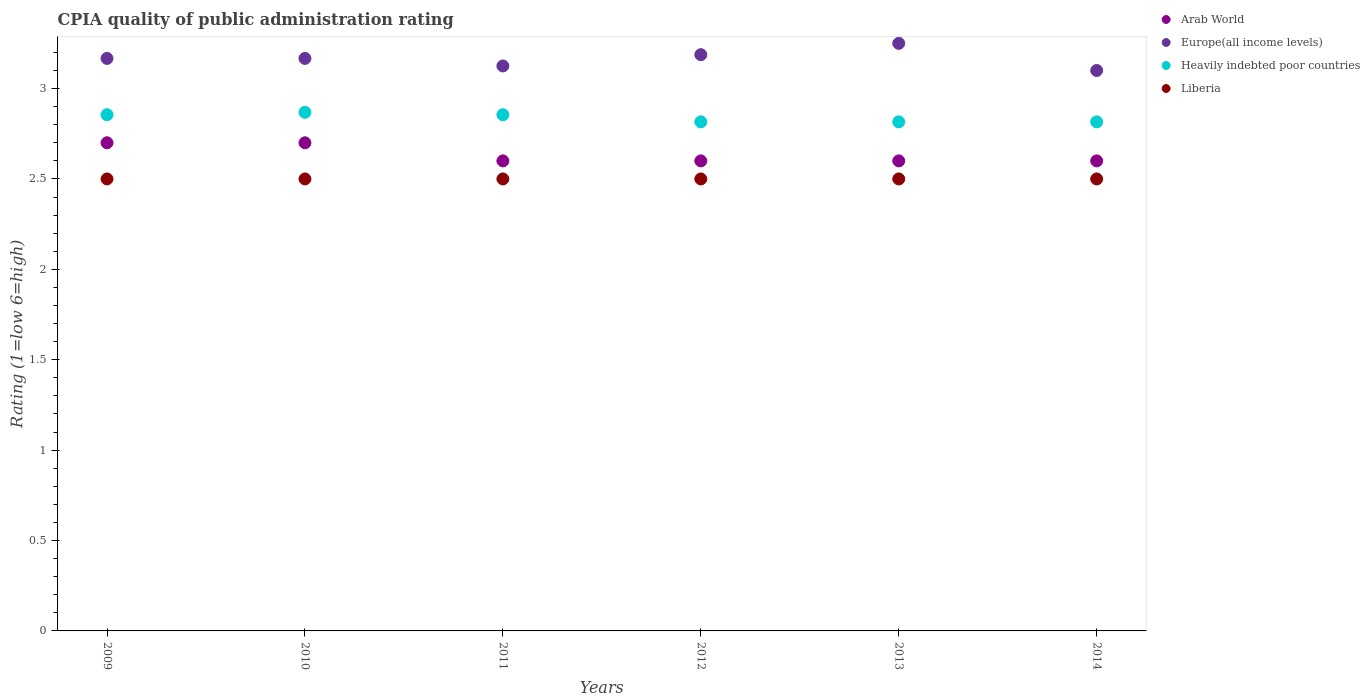How many different coloured dotlines are there?
Give a very brief answer. 4. Is the number of dotlines equal to the number of legend labels?
Ensure brevity in your answer.  Yes. What is the CPIA rating in Liberia in 2009?
Ensure brevity in your answer.  2.5. Across all years, what is the minimum CPIA rating in Heavily indebted poor countries?
Your response must be concise. 2.82. What is the total CPIA rating in Europe(all income levels) in the graph?
Your response must be concise. 19. What is the difference between the CPIA rating in Liberia in 2013 and that in 2014?
Offer a terse response. 0. What is the difference between the CPIA rating in Arab World in 2013 and the CPIA rating in Liberia in 2010?
Ensure brevity in your answer.  0.1. What is the average CPIA rating in Europe(all income levels) per year?
Your answer should be very brief. 3.17. In the year 2014, what is the difference between the CPIA rating in Europe(all income levels) and CPIA rating in Heavily indebted poor countries?
Ensure brevity in your answer.  0.28. In how many years, is the CPIA rating in Europe(all income levels) greater than 0.30000000000000004?
Provide a succinct answer. 6. What is the ratio of the CPIA rating in Liberia in 2009 to that in 2012?
Your response must be concise. 1. Is the CPIA rating in Liberia in 2011 less than that in 2014?
Your answer should be very brief. No. Is the difference between the CPIA rating in Europe(all income levels) in 2009 and 2012 greater than the difference between the CPIA rating in Heavily indebted poor countries in 2009 and 2012?
Make the answer very short. No. What is the difference between the highest and the second highest CPIA rating in Liberia?
Your response must be concise. 0. Is it the case that in every year, the sum of the CPIA rating in Liberia and CPIA rating in Heavily indebted poor countries  is greater than the sum of CPIA rating in Arab World and CPIA rating in Europe(all income levels)?
Offer a terse response. No. Is it the case that in every year, the sum of the CPIA rating in Arab World and CPIA rating in Europe(all income levels)  is greater than the CPIA rating in Heavily indebted poor countries?
Provide a short and direct response. Yes. Does the CPIA rating in Europe(all income levels) monotonically increase over the years?
Your answer should be very brief. No. How many dotlines are there?
Keep it short and to the point. 4. Are the values on the major ticks of Y-axis written in scientific E-notation?
Ensure brevity in your answer.  No. Does the graph contain any zero values?
Your answer should be very brief. No. How are the legend labels stacked?
Keep it short and to the point. Vertical. What is the title of the graph?
Your response must be concise. CPIA quality of public administration rating. Does "Zambia" appear as one of the legend labels in the graph?
Provide a succinct answer. No. What is the label or title of the Y-axis?
Your answer should be compact. Rating (1=low 6=high). What is the Rating (1=low 6=high) in Europe(all income levels) in 2009?
Your answer should be compact. 3.17. What is the Rating (1=low 6=high) in Heavily indebted poor countries in 2009?
Provide a short and direct response. 2.86. What is the Rating (1=low 6=high) of Europe(all income levels) in 2010?
Your response must be concise. 3.17. What is the Rating (1=low 6=high) in Heavily indebted poor countries in 2010?
Keep it short and to the point. 2.87. What is the Rating (1=low 6=high) of Arab World in 2011?
Provide a short and direct response. 2.6. What is the Rating (1=low 6=high) of Europe(all income levels) in 2011?
Provide a succinct answer. 3.12. What is the Rating (1=low 6=high) of Heavily indebted poor countries in 2011?
Keep it short and to the point. 2.86. What is the Rating (1=low 6=high) of Liberia in 2011?
Make the answer very short. 2.5. What is the Rating (1=low 6=high) of Europe(all income levels) in 2012?
Provide a succinct answer. 3.19. What is the Rating (1=low 6=high) in Heavily indebted poor countries in 2012?
Give a very brief answer. 2.82. What is the Rating (1=low 6=high) of Liberia in 2012?
Keep it short and to the point. 2.5. What is the Rating (1=low 6=high) of Arab World in 2013?
Your answer should be very brief. 2.6. What is the Rating (1=low 6=high) in Heavily indebted poor countries in 2013?
Your response must be concise. 2.82. What is the Rating (1=low 6=high) in Liberia in 2013?
Ensure brevity in your answer.  2.5. What is the Rating (1=low 6=high) of Heavily indebted poor countries in 2014?
Ensure brevity in your answer.  2.82. What is the Rating (1=low 6=high) in Liberia in 2014?
Give a very brief answer. 2.5. Across all years, what is the maximum Rating (1=low 6=high) in Heavily indebted poor countries?
Give a very brief answer. 2.87. Across all years, what is the minimum Rating (1=low 6=high) in Heavily indebted poor countries?
Give a very brief answer. 2.82. Across all years, what is the minimum Rating (1=low 6=high) of Liberia?
Make the answer very short. 2.5. What is the total Rating (1=low 6=high) of Arab World in the graph?
Offer a terse response. 15.8. What is the total Rating (1=low 6=high) in Europe(all income levels) in the graph?
Provide a short and direct response. 19. What is the total Rating (1=low 6=high) in Heavily indebted poor countries in the graph?
Ensure brevity in your answer.  17.03. What is the total Rating (1=low 6=high) of Liberia in the graph?
Provide a succinct answer. 15. What is the difference between the Rating (1=low 6=high) in Arab World in 2009 and that in 2010?
Keep it short and to the point. 0. What is the difference between the Rating (1=low 6=high) in Europe(all income levels) in 2009 and that in 2010?
Provide a short and direct response. 0. What is the difference between the Rating (1=low 6=high) in Heavily indebted poor countries in 2009 and that in 2010?
Offer a terse response. -0.01. What is the difference between the Rating (1=low 6=high) of Europe(all income levels) in 2009 and that in 2011?
Your answer should be very brief. 0.04. What is the difference between the Rating (1=low 6=high) in Heavily indebted poor countries in 2009 and that in 2011?
Your answer should be compact. 0. What is the difference between the Rating (1=low 6=high) in Europe(all income levels) in 2009 and that in 2012?
Provide a short and direct response. -0.02. What is the difference between the Rating (1=low 6=high) in Heavily indebted poor countries in 2009 and that in 2012?
Keep it short and to the point. 0.04. What is the difference between the Rating (1=low 6=high) in Europe(all income levels) in 2009 and that in 2013?
Ensure brevity in your answer.  -0.08. What is the difference between the Rating (1=low 6=high) of Heavily indebted poor countries in 2009 and that in 2013?
Make the answer very short. 0.04. What is the difference between the Rating (1=low 6=high) of Europe(all income levels) in 2009 and that in 2014?
Your response must be concise. 0.07. What is the difference between the Rating (1=low 6=high) of Heavily indebted poor countries in 2009 and that in 2014?
Ensure brevity in your answer.  0.04. What is the difference between the Rating (1=low 6=high) in Europe(all income levels) in 2010 and that in 2011?
Keep it short and to the point. 0.04. What is the difference between the Rating (1=low 6=high) of Heavily indebted poor countries in 2010 and that in 2011?
Provide a succinct answer. 0.01. What is the difference between the Rating (1=low 6=high) in Liberia in 2010 and that in 2011?
Ensure brevity in your answer.  0. What is the difference between the Rating (1=low 6=high) in Arab World in 2010 and that in 2012?
Give a very brief answer. 0.1. What is the difference between the Rating (1=low 6=high) of Europe(all income levels) in 2010 and that in 2012?
Provide a short and direct response. -0.02. What is the difference between the Rating (1=low 6=high) of Heavily indebted poor countries in 2010 and that in 2012?
Provide a succinct answer. 0.05. What is the difference between the Rating (1=low 6=high) in Liberia in 2010 and that in 2012?
Give a very brief answer. 0. What is the difference between the Rating (1=low 6=high) of Arab World in 2010 and that in 2013?
Provide a succinct answer. 0.1. What is the difference between the Rating (1=low 6=high) of Europe(all income levels) in 2010 and that in 2013?
Your response must be concise. -0.08. What is the difference between the Rating (1=low 6=high) of Heavily indebted poor countries in 2010 and that in 2013?
Provide a succinct answer. 0.05. What is the difference between the Rating (1=low 6=high) of Europe(all income levels) in 2010 and that in 2014?
Offer a terse response. 0.07. What is the difference between the Rating (1=low 6=high) in Heavily indebted poor countries in 2010 and that in 2014?
Provide a succinct answer. 0.05. What is the difference between the Rating (1=low 6=high) in Liberia in 2010 and that in 2014?
Provide a short and direct response. 0. What is the difference between the Rating (1=low 6=high) in Arab World in 2011 and that in 2012?
Provide a short and direct response. 0. What is the difference between the Rating (1=low 6=high) in Europe(all income levels) in 2011 and that in 2012?
Offer a very short reply. -0.06. What is the difference between the Rating (1=low 6=high) in Heavily indebted poor countries in 2011 and that in 2012?
Keep it short and to the point. 0.04. What is the difference between the Rating (1=low 6=high) of Liberia in 2011 and that in 2012?
Ensure brevity in your answer.  0. What is the difference between the Rating (1=low 6=high) in Europe(all income levels) in 2011 and that in 2013?
Your answer should be compact. -0.12. What is the difference between the Rating (1=low 6=high) in Heavily indebted poor countries in 2011 and that in 2013?
Make the answer very short. 0.04. What is the difference between the Rating (1=low 6=high) of Liberia in 2011 and that in 2013?
Your answer should be compact. 0. What is the difference between the Rating (1=low 6=high) of Arab World in 2011 and that in 2014?
Offer a terse response. 0. What is the difference between the Rating (1=low 6=high) in Europe(all income levels) in 2011 and that in 2014?
Your response must be concise. 0.03. What is the difference between the Rating (1=low 6=high) in Heavily indebted poor countries in 2011 and that in 2014?
Make the answer very short. 0.04. What is the difference between the Rating (1=low 6=high) in Liberia in 2011 and that in 2014?
Keep it short and to the point. 0. What is the difference between the Rating (1=low 6=high) of Arab World in 2012 and that in 2013?
Offer a very short reply. 0. What is the difference between the Rating (1=low 6=high) of Europe(all income levels) in 2012 and that in 2013?
Your answer should be compact. -0.06. What is the difference between the Rating (1=low 6=high) of Europe(all income levels) in 2012 and that in 2014?
Make the answer very short. 0.09. What is the difference between the Rating (1=low 6=high) in Liberia in 2012 and that in 2014?
Provide a succinct answer. 0. What is the difference between the Rating (1=low 6=high) of Arab World in 2013 and that in 2014?
Your answer should be compact. 0. What is the difference between the Rating (1=low 6=high) in Europe(all income levels) in 2013 and that in 2014?
Offer a terse response. 0.15. What is the difference between the Rating (1=low 6=high) in Arab World in 2009 and the Rating (1=low 6=high) in Europe(all income levels) in 2010?
Provide a short and direct response. -0.47. What is the difference between the Rating (1=low 6=high) of Arab World in 2009 and the Rating (1=low 6=high) of Heavily indebted poor countries in 2010?
Ensure brevity in your answer.  -0.17. What is the difference between the Rating (1=low 6=high) of Europe(all income levels) in 2009 and the Rating (1=low 6=high) of Heavily indebted poor countries in 2010?
Ensure brevity in your answer.  0.3. What is the difference between the Rating (1=low 6=high) in Europe(all income levels) in 2009 and the Rating (1=low 6=high) in Liberia in 2010?
Give a very brief answer. 0.67. What is the difference between the Rating (1=low 6=high) of Heavily indebted poor countries in 2009 and the Rating (1=low 6=high) of Liberia in 2010?
Provide a short and direct response. 0.36. What is the difference between the Rating (1=low 6=high) in Arab World in 2009 and the Rating (1=low 6=high) in Europe(all income levels) in 2011?
Your answer should be very brief. -0.42. What is the difference between the Rating (1=low 6=high) of Arab World in 2009 and the Rating (1=low 6=high) of Heavily indebted poor countries in 2011?
Make the answer very short. -0.16. What is the difference between the Rating (1=low 6=high) in Europe(all income levels) in 2009 and the Rating (1=low 6=high) in Heavily indebted poor countries in 2011?
Offer a very short reply. 0.31. What is the difference between the Rating (1=low 6=high) of Heavily indebted poor countries in 2009 and the Rating (1=low 6=high) of Liberia in 2011?
Offer a terse response. 0.36. What is the difference between the Rating (1=low 6=high) of Arab World in 2009 and the Rating (1=low 6=high) of Europe(all income levels) in 2012?
Provide a short and direct response. -0.49. What is the difference between the Rating (1=low 6=high) of Arab World in 2009 and the Rating (1=low 6=high) of Heavily indebted poor countries in 2012?
Provide a short and direct response. -0.12. What is the difference between the Rating (1=low 6=high) in Europe(all income levels) in 2009 and the Rating (1=low 6=high) in Heavily indebted poor countries in 2012?
Provide a short and direct response. 0.35. What is the difference between the Rating (1=low 6=high) of Europe(all income levels) in 2009 and the Rating (1=low 6=high) of Liberia in 2012?
Your response must be concise. 0.67. What is the difference between the Rating (1=low 6=high) in Heavily indebted poor countries in 2009 and the Rating (1=low 6=high) in Liberia in 2012?
Offer a terse response. 0.36. What is the difference between the Rating (1=low 6=high) in Arab World in 2009 and the Rating (1=low 6=high) in Europe(all income levels) in 2013?
Your response must be concise. -0.55. What is the difference between the Rating (1=low 6=high) in Arab World in 2009 and the Rating (1=low 6=high) in Heavily indebted poor countries in 2013?
Make the answer very short. -0.12. What is the difference between the Rating (1=low 6=high) in Europe(all income levels) in 2009 and the Rating (1=low 6=high) in Heavily indebted poor countries in 2013?
Provide a short and direct response. 0.35. What is the difference between the Rating (1=low 6=high) of Europe(all income levels) in 2009 and the Rating (1=low 6=high) of Liberia in 2013?
Your response must be concise. 0.67. What is the difference between the Rating (1=low 6=high) of Heavily indebted poor countries in 2009 and the Rating (1=low 6=high) of Liberia in 2013?
Your answer should be very brief. 0.36. What is the difference between the Rating (1=low 6=high) of Arab World in 2009 and the Rating (1=low 6=high) of Europe(all income levels) in 2014?
Make the answer very short. -0.4. What is the difference between the Rating (1=low 6=high) in Arab World in 2009 and the Rating (1=low 6=high) in Heavily indebted poor countries in 2014?
Keep it short and to the point. -0.12. What is the difference between the Rating (1=low 6=high) of Europe(all income levels) in 2009 and the Rating (1=low 6=high) of Heavily indebted poor countries in 2014?
Provide a succinct answer. 0.35. What is the difference between the Rating (1=low 6=high) in Europe(all income levels) in 2009 and the Rating (1=low 6=high) in Liberia in 2014?
Provide a short and direct response. 0.67. What is the difference between the Rating (1=low 6=high) of Heavily indebted poor countries in 2009 and the Rating (1=low 6=high) of Liberia in 2014?
Your answer should be very brief. 0.36. What is the difference between the Rating (1=low 6=high) of Arab World in 2010 and the Rating (1=low 6=high) of Europe(all income levels) in 2011?
Offer a terse response. -0.42. What is the difference between the Rating (1=low 6=high) in Arab World in 2010 and the Rating (1=low 6=high) in Heavily indebted poor countries in 2011?
Offer a very short reply. -0.16. What is the difference between the Rating (1=low 6=high) in Europe(all income levels) in 2010 and the Rating (1=low 6=high) in Heavily indebted poor countries in 2011?
Give a very brief answer. 0.31. What is the difference between the Rating (1=low 6=high) in Heavily indebted poor countries in 2010 and the Rating (1=low 6=high) in Liberia in 2011?
Provide a short and direct response. 0.37. What is the difference between the Rating (1=low 6=high) of Arab World in 2010 and the Rating (1=low 6=high) of Europe(all income levels) in 2012?
Offer a very short reply. -0.49. What is the difference between the Rating (1=low 6=high) in Arab World in 2010 and the Rating (1=low 6=high) in Heavily indebted poor countries in 2012?
Provide a short and direct response. -0.12. What is the difference between the Rating (1=low 6=high) of Europe(all income levels) in 2010 and the Rating (1=low 6=high) of Heavily indebted poor countries in 2012?
Provide a short and direct response. 0.35. What is the difference between the Rating (1=low 6=high) of Europe(all income levels) in 2010 and the Rating (1=low 6=high) of Liberia in 2012?
Provide a short and direct response. 0.67. What is the difference between the Rating (1=low 6=high) in Heavily indebted poor countries in 2010 and the Rating (1=low 6=high) in Liberia in 2012?
Give a very brief answer. 0.37. What is the difference between the Rating (1=low 6=high) of Arab World in 2010 and the Rating (1=low 6=high) of Europe(all income levels) in 2013?
Keep it short and to the point. -0.55. What is the difference between the Rating (1=low 6=high) of Arab World in 2010 and the Rating (1=low 6=high) of Heavily indebted poor countries in 2013?
Provide a short and direct response. -0.12. What is the difference between the Rating (1=low 6=high) of Arab World in 2010 and the Rating (1=low 6=high) of Liberia in 2013?
Provide a short and direct response. 0.2. What is the difference between the Rating (1=low 6=high) in Europe(all income levels) in 2010 and the Rating (1=low 6=high) in Heavily indebted poor countries in 2013?
Provide a succinct answer. 0.35. What is the difference between the Rating (1=low 6=high) in Europe(all income levels) in 2010 and the Rating (1=low 6=high) in Liberia in 2013?
Your answer should be very brief. 0.67. What is the difference between the Rating (1=low 6=high) of Heavily indebted poor countries in 2010 and the Rating (1=low 6=high) of Liberia in 2013?
Your answer should be very brief. 0.37. What is the difference between the Rating (1=low 6=high) in Arab World in 2010 and the Rating (1=low 6=high) in Europe(all income levels) in 2014?
Give a very brief answer. -0.4. What is the difference between the Rating (1=low 6=high) of Arab World in 2010 and the Rating (1=low 6=high) of Heavily indebted poor countries in 2014?
Provide a short and direct response. -0.12. What is the difference between the Rating (1=low 6=high) in Arab World in 2010 and the Rating (1=low 6=high) in Liberia in 2014?
Keep it short and to the point. 0.2. What is the difference between the Rating (1=low 6=high) of Europe(all income levels) in 2010 and the Rating (1=low 6=high) of Heavily indebted poor countries in 2014?
Your response must be concise. 0.35. What is the difference between the Rating (1=low 6=high) of Europe(all income levels) in 2010 and the Rating (1=low 6=high) of Liberia in 2014?
Make the answer very short. 0.67. What is the difference between the Rating (1=low 6=high) in Heavily indebted poor countries in 2010 and the Rating (1=low 6=high) in Liberia in 2014?
Your answer should be very brief. 0.37. What is the difference between the Rating (1=low 6=high) in Arab World in 2011 and the Rating (1=low 6=high) in Europe(all income levels) in 2012?
Your answer should be very brief. -0.59. What is the difference between the Rating (1=low 6=high) of Arab World in 2011 and the Rating (1=low 6=high) of Heavily indebted poor countries in 2012?
Ensure brevity in your answer.  -0.22. What is the difference between the Rating (1=low 6=high) of Europe(all income levels) in 2011 and the Rating (1=low 6=high) of Heavily indebted poor countries in 2012?
Make the answer very short. 0.31. What is the difference between the Rating (1=low 6=high) of Europe(all income levels) in 2011 and the Rating (1=low 6=high) of Liberia in 2012?
Ensure brevity in your answer.  0.62. What is the difference between the Rating (1=low 6=high) in Heavily indebted poor countries in 2011 and the Rating (1=low 6=high) in Liberia in 2012?
Offer a very short reply. 0.36. What is the difference between the Rating (1=low 6=high) of Arab World in 2011 and the Rating (1=low 6=high) of Europe(all income levels) in 2013?
Make the answer very short. -0.65. What is the difference between the Rating (1=low 6=high) in Arab World in 2011 and the Rating (1=low 6=high) in Heavily indebted poor countries in 2013?
Ensure brevity in your answer.  -0.22. What is the difference between the Rating (1=low 6=high) in Europe(all income levels) in 2011 and the Rating (1=low 6=high) in Heavily indebted poor countries in 2013?
Give a very brief answer. 0.31. What is the difference between the Rating (1=low 6=high) in Heavily indebted poor countries in 2011 and the Rating (1=low 6=high) in Liberia in 2013?
Your response must be concise. 0.36. What is the difference between the Rating (1=low 6=high) of Arab World in 2011 and the Rating (1=low 6=high) of Heavily indebted poor countries in 2014?
Give a very brief answer. -0.22. What is the difference between the Rating (1=low 6=high) in Arab World in 2011 and the Rating (1=low 6=high) in Liberia in 2014?
Keep it short and to the point. 0.1. What is the difference between the Rating (1=low 6=high) in Europe(all income levels) in 2011 and the Rating (1=low 6=high) in Heavily indebted poor countries in 2014?
Keep it short and to the point. 0.31. What is the difference between the Rating (1=low 6=high) in Heavily indebted poor countries in 2011 and the Rating (1=low 6=high) in Liberia in 2014?
Make the answer very short. 0.36. What is the difference between the Rating (1=low 6=high) in Arab World in 2012 and the Rating (1=low 6=high) in Europe(all income levels) in 2013?
Provide a short and direct response. -0.65. What is the difference between the Rating (1=low 6=high) in Arab World in 2012 and the Rating (1=low 6=high) in Heavily indebted poor countries in 2013?
Provide a short and direct response. -0.22. What is the difference between the Rating (1=low 6=high) in Europe(all income levels) in 2012 and the Rating (1=low 6=high) in Heavily indebted poor countries in 2013?
Make the answer very short. 0.37. What is the difference between the Rating (1=low 6=high) in Europe(all income levels) in 2012 and the Rating (1=low 6=high) in Liberia in 2013?
Make the answer very short. 0.69. What is the difference between the Rating (1=low 6=high) of Heavily indebted poor countries in 2012 and the Rating (1=low 6=high) of Liberia in 2013?
Provide a succinct answer. 0.32. What is the difference between the Rating (1=low 6=high) in Arab World in 2012 and the Rating (1=low 6=high) in Heavily indebted poor countries in 2014?
Make the answer very short. -0.22. What is the difference between the Rating (1=low 6=high) of Europe(all income levels) in 2012 and the Rating (1=low 6=high) of Heavily indebted poor countries in 2014?
Give a very brief answer. 0.37. What is the difference between the Rating (1=low 6=high) in Europe(all income levels) in 2012 and the Rating (1=low 6=high) in Liberia in 2014?
Provide a short and direct response. 0.69. What is the difference between the Rating (1=low 6=high) in Heavily indebted poor countries in 2012 and the Rating (1=low 6=high) in Liberia in 2014?
Provide a short and direct response. 0.32. What is the difference between the Rating (1=low 6=high) in Arab World in 2013 and the Rating (1=low 6=high) in Europe(all income levels) in 2014?
Provide a short and direct response. -0.5. What is the difference between the Rating (1=low 6=high) in Arab World in 2013 and the Rating (1=low 6=high) in Heavily indebted poor countries in 2014?
Your response must be concise. -0.22. What is the difference between the Rating (1=low 6=high) of Arab World in 2013 and the Rating (1=low 6=high) of Liberia in 2014?
Make the answer very short. 0.1. What is the difference between the Rating (1=low 6=high) in Europe(all income levels) in 2013 and the Rating (1=low 6=high) in Heavily indebted poor countries in 2014?
Provide a succinct answer. 0.43. What is the difference between the Rating (1=low 6=high) of Heavily indebted poor countries in 2013 and the Rating (1=low 6=high) of Liberia in 2014?
Provide a short and direct response. 0.32. What is the average Rating (1=low 6=high) in Arab World per year?
Provide a succinct answer. 2.63. What is the average Rating (1=low 6=high) of Europe(all income levels) per year?
Ensure brevity in your answer.  3.17. What is the average Rating (1=low 6=high) in Heavily indebted poor countries per year?
Keep it short and to the point. 2.84. In the year 2009, what is the difference between the Rating (1=low 6=high) of Arab World and Rating (1=low 6=high) of Europe(all income levels)?
Give a very brief answer. -0.47. In the year 2009, what is the difference between the Rating (1=low 6=high) in Arab World and Rating (1=low 6=high) in Heavily indebted poor countries?
Make the answer very short. -0.16. In the year 2009, what is the difference between the Rating (1=low 6=high) of Europe(all income levels) and Rating (1=low 6=high) of Heavily indebted poor countries?
Your answer should be compact. 0.31. In the year 2009, what is the difference between the Rating (1=low 6=high) of Heavily indebted poor countries and Rating (1=low 6=high) of Liberia?
Your answer should be compact. 0.36. In the year 2010, what is the difference between the Rating (1=low 6=high) of Arab World and Rating (1=low 6=high) of Europe(all income levels)?
Your answer should be compact. -0.47. In the year 2010, what is the difference between the Rating (1=low 6=high) in Arab World and Rating (1=low 6=high) in Heavily indebted poor countries?
Your response must be concise. -0.17. In the year 2010, what is the difference between the Rating (1=low 6=high) of Arab World and Rating (1=low 6=high) of Liberia?
Offer a terse response. 0.2. In the year 2010, what is the difference between the Rating (1=low 6=high) in Europe(all income levels) and Rating (1=low 6=high) in Heavily indebted poor countries?
Provide a short and direct response. 0.3. In the year 2010, what is the difference between the Rating (1=low 6=high) in Europe(all income levels) and Rating (1=low 6=high) in Liberia?
Your response must be concise. 0.67. In the year 2010, what is the difference between the Rating (1=low 6=high) in Heavily indebted poor countries and Rating (1=low 6=high) in Liberia?
Your answer should be very brief. 0.37. In the year 2011, what is the difference between the Rating (1=low 6=high) in Arab World and Rating (1=low 6=high) in Europe(all income levels)?
Your answer should be compact. -0.53. In the year 2011, what is the difference between the Rating (1=low 6=high) of Arab World and Rating (1=low 6=high) of Heavily indebted poor countries?
Ensure brevity in your answer.  -0.26. In the year 2011, what is the difference between the Rating (1=low 6=high) of Europe(all income levels) and Rating (1=low 6=high) of Heavily indebted poor countries?
Ensure brevity in your answer.  0.27. In the year 2011, what is the difference between the Rating (1=low 6=high) of Heavily indebted poor countries and Rating (1=low 6=high) of Liberia?
Give a very brief answer. 0.36. In the year 2012, what is the difference between the Rating (1=low 6=high) in Arab World and Rating (1=low 6=high) in Europe(all income levels)?
Your answer should be compact. -0.59. In the year 2012, what is the difference between the Rating (1=low 6=high) in Arab World and Rating (1=low 6=high) in Heavily indebted poor countries?
Ensure brevity in your answer.  -0.22. In the year 2012, what is the difference between the Rating (1=low 6=high) of Europe(all income levels) and Rating (1=low 6=high) of Heavily indebted poor countries?
Ensure brevity in your answer.  0.37. In the year 2012, what is the difference between the Rating (1=low 6=high) in Europe(all income levels) and Rating (1=low 6=high) in Liberia?
Offer a very short reply. 0.69. In the year 2012, what is the difference between the Rating (1=low 6=high) of Heavily indebted poor countries and Rating (1=low 6=high) of Liberia?
Offer a terse response. 0.32. In the year 2013, what is the difference between the Rating (1=low 6=high) in Arab World and Rating (1=low 6=high) in Europe(all income levels)?
Offer a terse response. -0.65. In the year 2013, what is the difference between the Rating (1=low 6=high) of Arab World and Rating (1=low 6=high) of Heavily indebted poor countries?
Offer a very short reply. -0.22. In the year 2013, what is the difference between the Rating (1=low 6=high) of Europe(all income levels) and Rating (1=low 6=high) of Heavily indebted poor countries?
Offer a terse response. 0.43. In the year 2013, what is the difference between the Rating (1=low 6=high) in Europe(all income levels) and Rating (1=low 6=high) in Liberia?
Your answer should be compact. 0.75. In the year 2013, what is the difference between the Rating (1=low 6=high) in Heavily indebted poor countries and Rating (1=low 6=high) in Liberia?
Your response must be concise. 0.32. In the year 2014, what is the difference between the Rating (1=low 6=high) of Arab World and Rating (1=low 6=high) of Heavily indebted poor countries?
Offer a very short reply. -0.22. In the year 2014, what is the difference between the Rating (1=low 6=high) of Arab World and Rating (1=low 6=high) of Liberia?
Your answer should be very brief. 0.1. In the year 2014, what is the difference between the Rating (1=low 6=high) of Europe(all income levels) and Rating (1=low 6=high) of Heavily indebted poor countries?
Your response must be concise. 0.28. In the year 2014, what is the difference between the Rating (1=low 6=high) in Heavily indebted poor countries and Rating (1=low 6=high) in Liberia?
Your answer should be compact. 0.32. What is the ratio of the Rating (1=low 6=high) in Arab World in 2009 to that in 2010?
Offer a very short reply. 1. What is the ratio of the Rating (1=low 6=high) of Arab World in 2009 to that in 2011?
Ensure brevity in your answer.  1.04. What is the ratio of the Rating (1=low 6=high) in Europe(all income levels) in 2009 to that in 2011?
Provide a succinct answer. 1.01. What is the ratio of the Rating (1=low 6=high) of Heavily indebted poor countries in 2009 to that in 2011?
Make the answer very short. 1. What is the ratio of the Rating (1=low 6=high) of Arab World in 2009 to that in 2012?
Give a very brief answer. 1.04. What is the ratio of the Rating (1=low 6=high) in Europe(all income levels) in 2009 to that in 2012?
Make the answer very short. 0.99. What is the ratio of the Rating (1=low 6=high) in Liberia in 2009 to that in 2012?
Provide a succinct answer. 1. What is the ratio of the Rating (1=low 6=high) of Europe(all income levels) in 2009 to that in 2013?
Your response must be concise. 0.97. What is the ratio of the Rating (1=low 6=high) of Heavily indebted poor countries in 2009 to that in 2013?
Ensure brevity in your answer.  1.01. What is the ratio of the Rating (1=low 6=high) in Europe(all income levels) in 2009 to that in 2014?
Ensure brevity in your answer.  1.02. What is the ratio of the Rating (1=low 6=high) in Arab World in 2010 to that in 2011?
Keep it short and to the point. 1.04. What is the ratio of the Rating (1=low 6=high) of Europe(all income levels) in 2010 to that in 2011?
Provide a succinct answer. 1.01. What is the ratio of the Rating (1=low 6=high) in Liberia in 2010 to that in 2011?
Make the answer very short. 1. What is the ratio of the Rating (1=low 6=high) of Heavily indebted poor countries in 2010 to that in 2012?
Make the answer very short. 1.02. What is the ratio of the Rating (1=low 6=high) in Liberia in 2010 to that in 2012?
Provide a short and direct response. 1. What is the ratio of the Rating (1=low 6=high) in Arab World in 2010 to that in 2013?
Provide a succinct answer. 1.04. What is the ratio of the Rating (1=low 6=high) in Europe(all income levels) in 2010 to that in 2013?
Provide a short and direct response. 0.97. What is the ratio of the Rating (1=low 6=high) in Heavily indebted poor countries in 2010 to that in 2013?
Your answer should be very brief. 1.02. What is the ratio of the Rating (1=low 6=high) in Liberia in 2010 to that in 2013?
Keep it short and to the point. 1. What is the ratio of the Rating (1=low 6=high) of Europe(all income levels) in 2010 to that in 2014?
Your answer should be very brief. 1.02. What is the ratio of the Rating (1=low 6=high) of Heavily indebted poor countries in 2010 to that in 2014?
Provide a short and direct response. 1.02. What is the ratio of the Rating (1=low 6=high) in Europe(all income levels) in 2011 to that in 2012?
Your answer should be very brief. 0.98. What is the ratio of the Rating (1=low 6=high) in Europe(all income levels) in 2011 to that in 2013?
Provide a succinct answer. 0.96. What is the ratio of the Rating (1=low 6=high) of Heavily indebted poor countries in 2011 to that in 2013?
Provide a short and direct response. 1.01. What is the ratio of the Rating (1=low 6=high) in Arab World in 2011 to that in 2014?
Give a very brief answer. 1. What is the ratio of the Rating (1=low 6=high) of Europe(all income levels) in 2011 to that in 2014?
Give a very brief answer. 1.01. What is the ratio of the Rating (1=low 6=high) of Heavily indebted poor countries in 2011 to that in 2014?
Provide a short and direct response. 1.01. What is the ratio of the Rating (1=low 6=high) in Liberia in 2011 to that in 2014?
Your answer should be very brief. 1. What is the ratio of the Rating (1=low 6=high) of Arab World in 2012 to that in 2013?
Give a very brief answer. 1. What is the ratio of the Rating (1=low 6=high) in Europe(all income levels) in 2012 to that in 2013?
Provide a succinct answer. 0.98. What is the ratio of the Rating (1=low 6=high) in Heavily indebted poor countries in 2012 to that in 2013?
Offer a very short reply. 1. What is the ratio of the Rating (1=low 6=high) of Arab World in 2012 to that in 2014?
Your answer should be compact. 1. What is the ratio of the Rating (1=low 6=high) of Europe(all income levels) in 2012 to that in 2014?
Ensure brevity in your answer.  1.03. What is the ratio of the Rating (1=low 6=high) of Liberia in 2012 to that in 2014?
Offer a terse response. 1. What is the ratio of the Rating (1=low 6=high) of Arab World in 2013 to that in 2014?
Your answer should be compact. 1. What is the ratio of the Rating (1=low 6=high) of Europe(all income levels) in 2013 to that in 2014?
Provide a short and direct response. 1.05. What is the ratio of the Rating (1=low 6=high) of Heavily indebted poor countries in 2013 to that in 2014?
Keep it short and to the point. 1. What is the difference between the highest and the second highest Rating (1=low 6=high) in Europe(all income levels)?
Ensure brevity in your answer.  0.06. What is the difference between the highest and the second highest Rating (1=low 6=high) of Heavily indebted poor countries?
Your answer should be compact. 0.01. What is the difference between the highest and the lowest Rating (1=low 6=high) in Heavily indebted poor countries?
Keep it short and to the point. 0.05. 